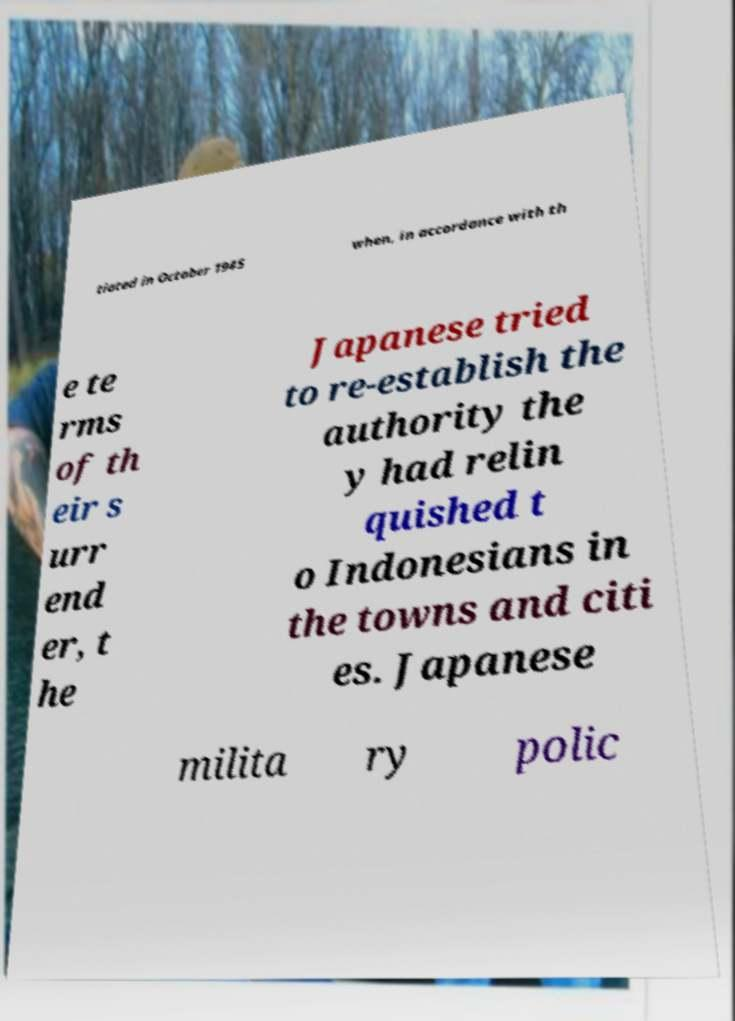Could you extract and type out the text from this image? tiated in October 1945 when, in accordance with th e te rms of th eir s urr end er, t he Japanese tried to re-establish the authority the y had relin quished t o Indonesians in the towns and citi es. Japanese milita ry polic 